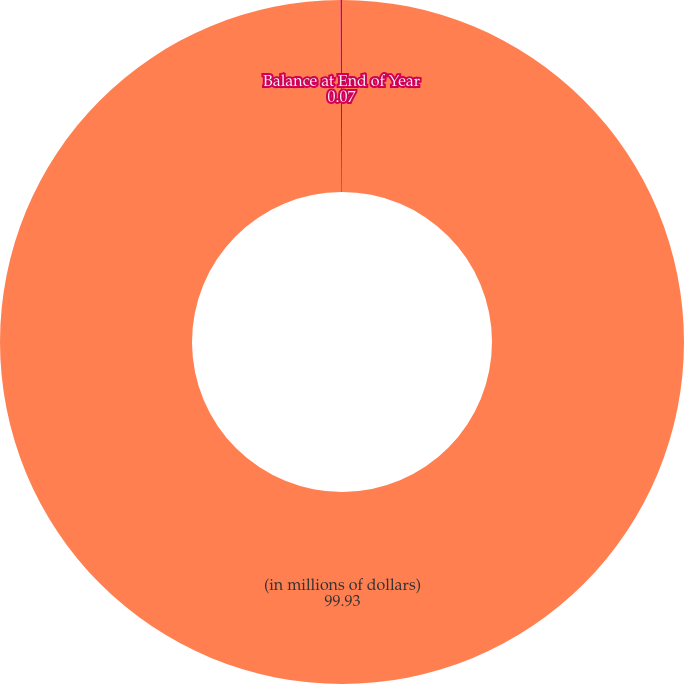Convert chart. <chart><loc_0><loc_0><loc_500><loc_500><pie_chart><fcel>(in millions of dollars)<fcel>Balance at End of Year<nl><fcel>99.93%<fcel>0.07%<nl></chart> 